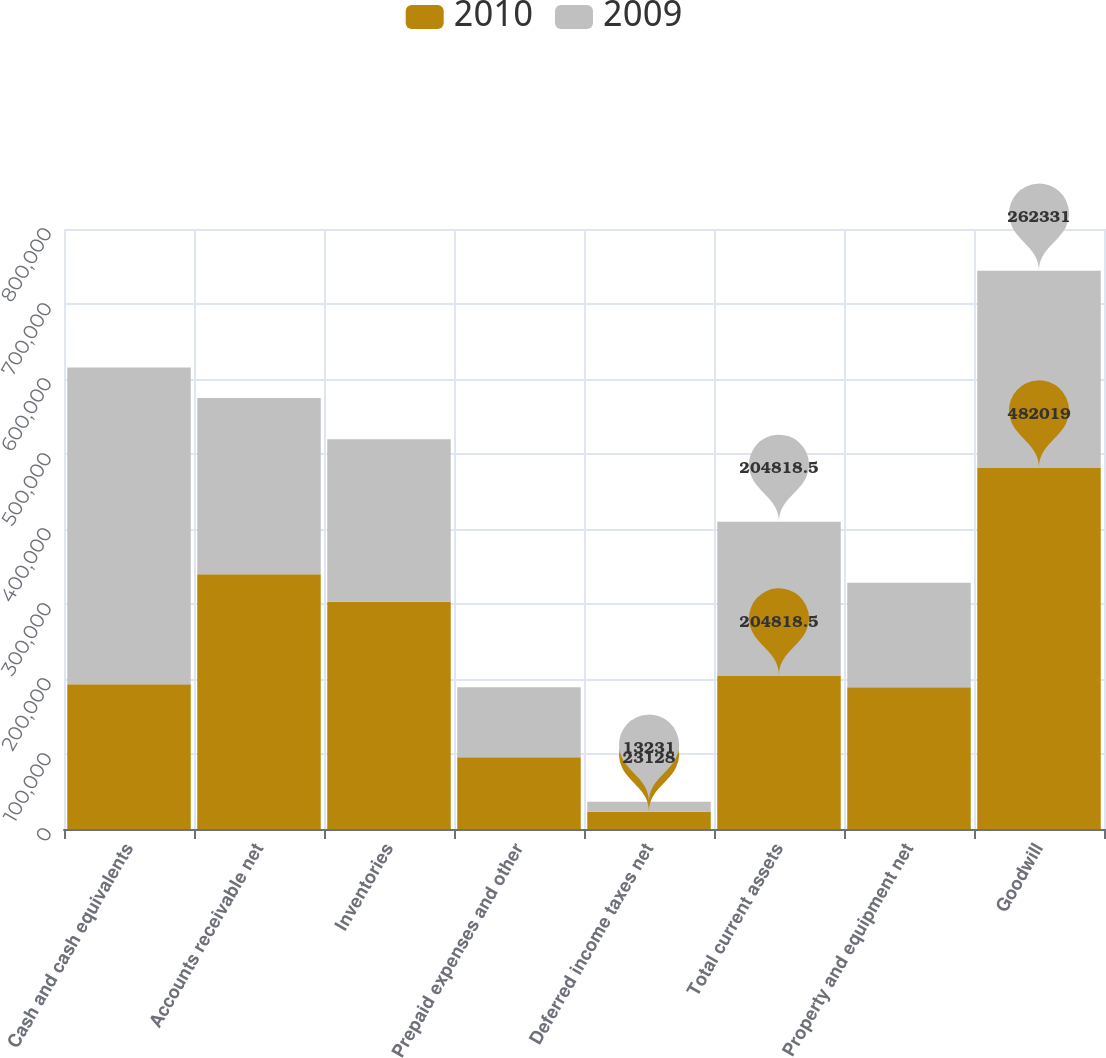Convert chart. <chart><loc_0><loc_0><loc_500><loc_500><stacked_bar_chart><ecel><fcel>Cash and cash equivalents<fcel>Accounts receivable net<fcel>Inventories<fcel>Prepaid expenses and other<fcel>Deferred income taxes net<fcel>Total current assets<fcel>Property and equipment net<fcel>Goodwill<nl><fcel>2010<fcel>193137<fcel>339723<fcel>303156<fcel>95663<fcel>23128<fcel>204818<fcel>189119<fcel>482019<nl><fcel>2009<fcel>422047<fcel>234974<fcel>216500<fcel>93276<fcel>13231<fcel>204818<fcel>139112<fcel>262331<nl></chart> 